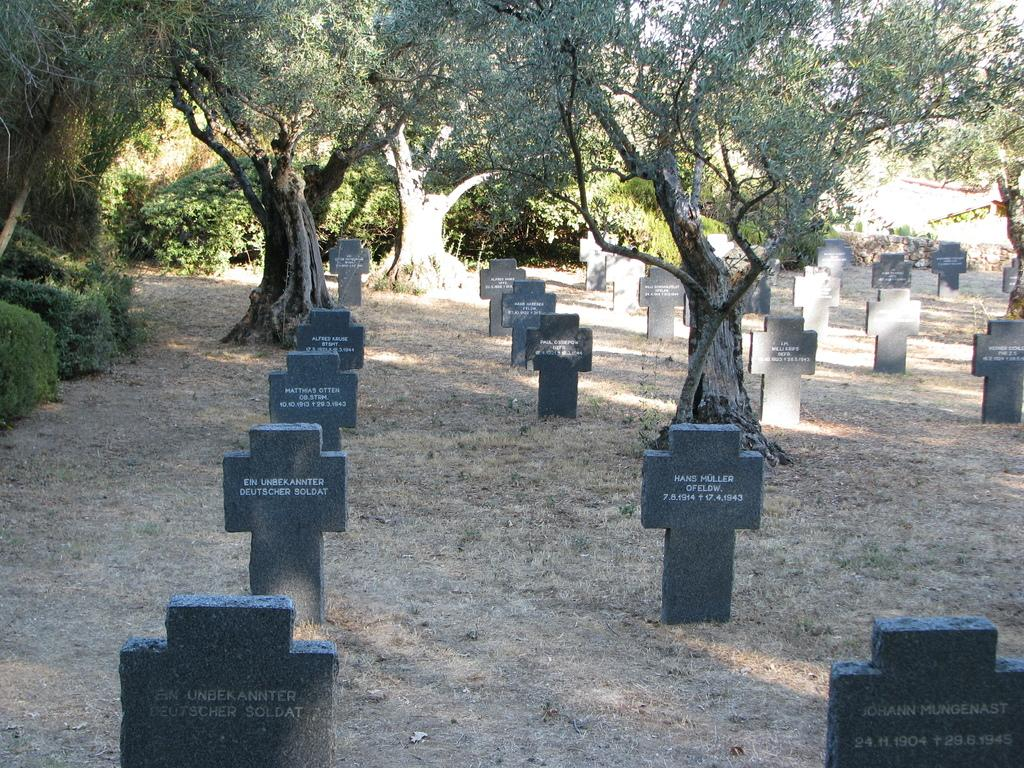Where was the image taken? The image was taken in a graveyard. What can be seen at the bottom of the image? There are graves at the bottom of the image. What is visible in the background of the image? There are trees in the background of the image. What is the process of digestion like for the trees in the image? The trees in the image do not have a digestive process, as they are not living organisms capable of digestion. 